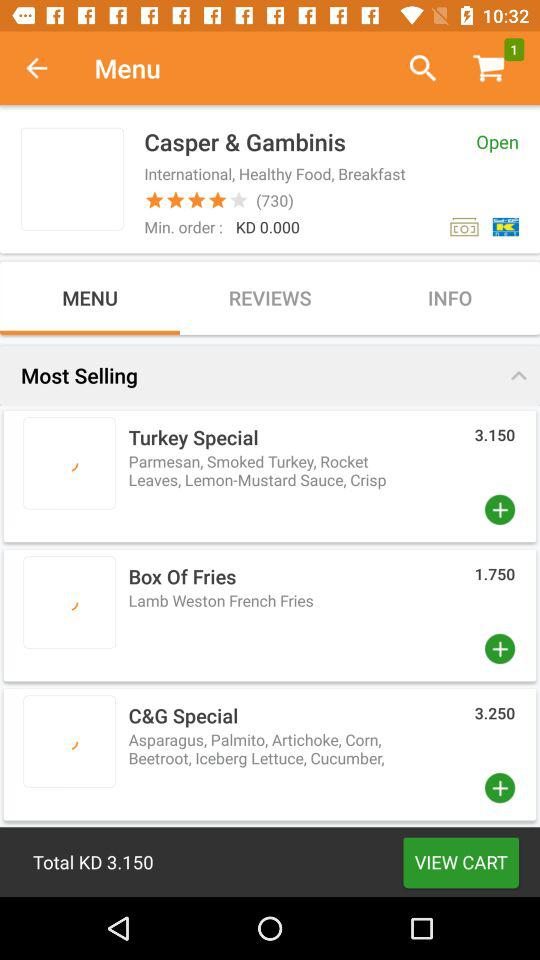What is the rating of "Casper & Gambinis"? The rating is 4 stars. 